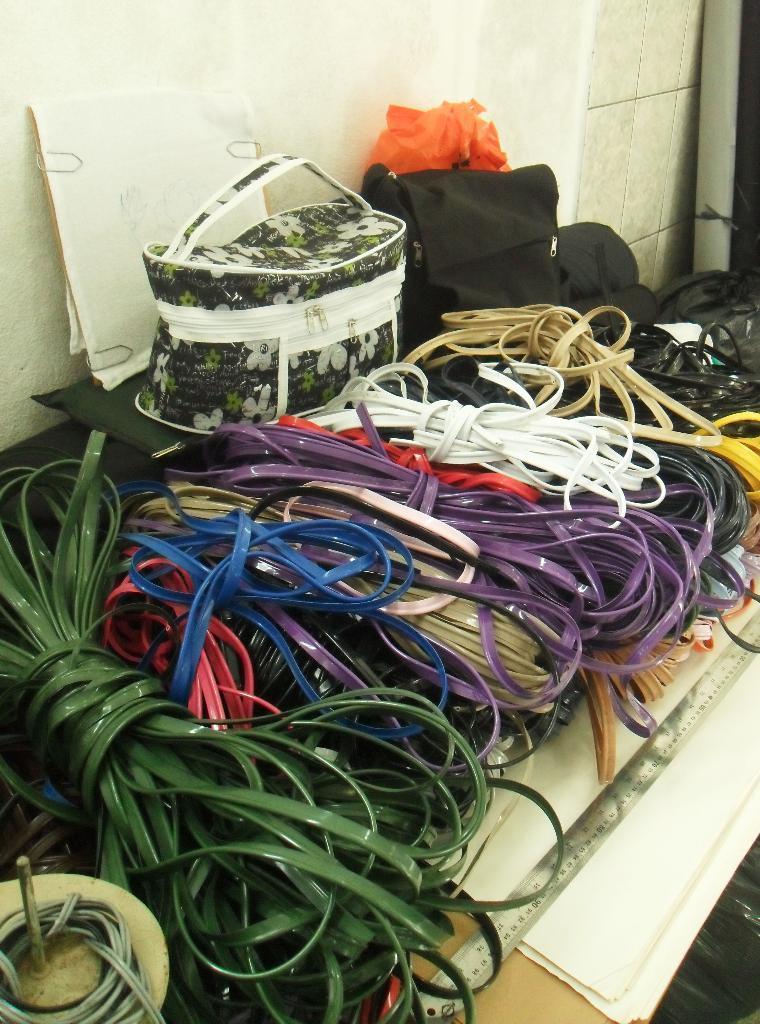Please provide a concise description of this image. In this image, There is a table which is yellow color on that table there are different different color ropes kept on the table, There is a steel rule on the table, In the middle there is a bag which is in green color, In the right side there is a black color bag kept on the table, In the background there is a white color wall. 